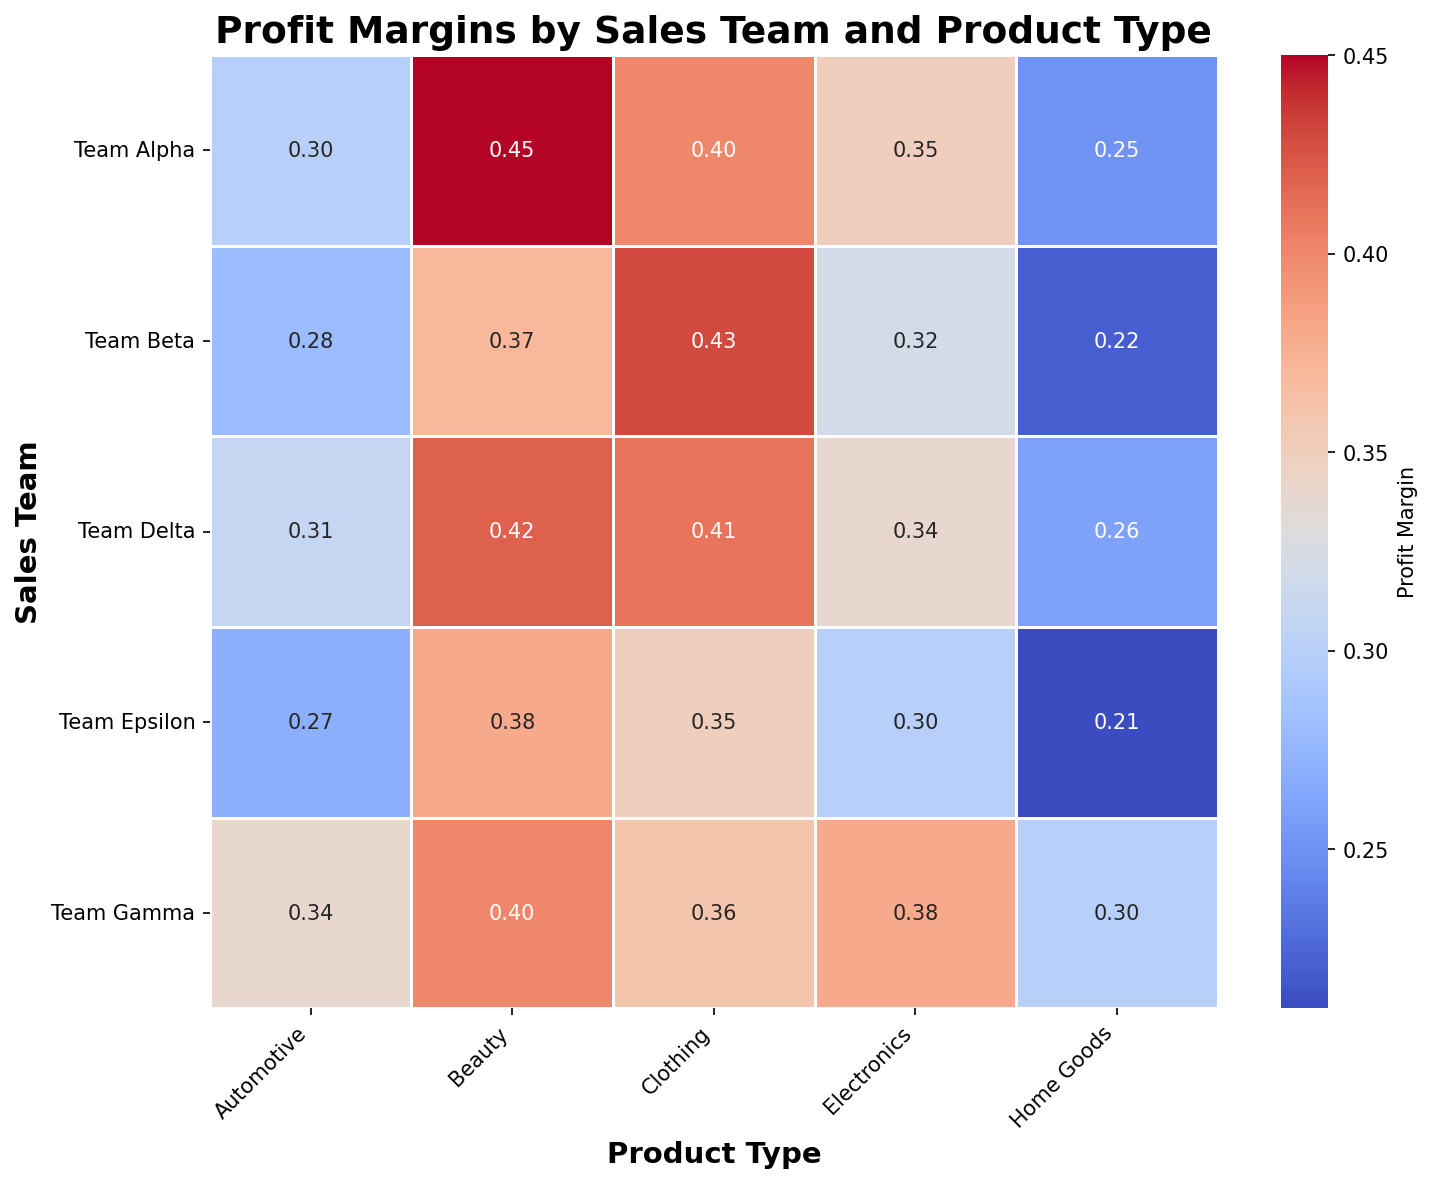What's the highest profit margin for Team Alpha? By looking at the heatmap, find the cell corresponding to Team Alpha with the highest profit margin. The color shade indicates this value visually. The highest annotated value for Team Alpha is 0.45 for the Beauty product type.
Answer: 0.45 How does the profit margin for Electronics compare between all sales teams? Compare the annotated values for the Electronics column across all teams. Team Gamma has the highest at 0.38, followed by Team Alpha at 0.35, Team Delta at 0.34, Team Beta at 0.32, and Team Epsilon at 0.30.
Answer: Team Gamma has the highest What is the average profit margin for Home Goods across all teams? Add all the profit margins for Home Goods: (0.25 + 0.22 + 0.30 + 0.26 + 0.21) = 1.24. Then divide by the number of teams (5): 1.24 / 5 = 0.248.
Answer: 0.248 Which team has the most diverse profit margins across product types? Look for the team with the widest range of values by visually scanning the heatmap. Team Alpha has the largest spread, with margins from 0.25 (Home Goods) to 0.45 (Beauty), a difference of 0.20.
Answer: Team Alpha Is there any product type where all teams have similar profit margins? Examine the color shades and annotated values for each product type. For Automotive, the margins are relatively close: 0.30, 0.28, 0.34, 0.31, and 0.27.
Answer: Automotive Which product type has the highest average profit margin overall? Find the average margin for each product type and compare. Adding Electronics (0.35 + 0.32 + 0.38 + 0.34 + 0.30 = 1.69, avg 0.338), Clothing (0.40 + 0.43 + 0.36 + 0.41 + 0.35 = 1.95, avg 0.39), Home Goods (0.25 + 0.22 + 0.30 + 0.26 + 0.21 = 1.24, avg 0.248), Automotive (0.30 + 0.28 + 0.34 + 0.31 + 0.27 = 1.5, avg 0.3), and Beauty (0.45 + 0.37 + 0.40 + 0.42 + 0.38 = 2.02, avg 0.404) shows Beauty has the highest average.
Answer: Beauty 